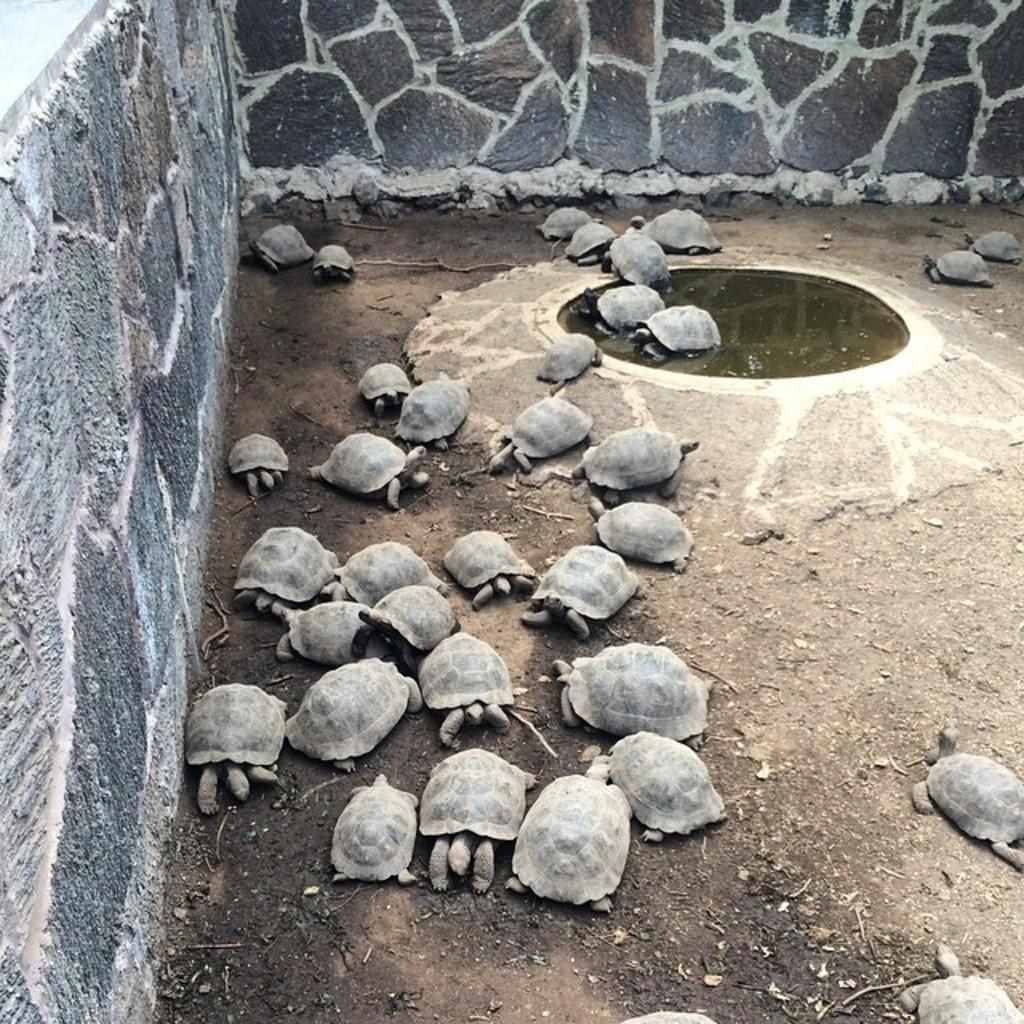What type of animals are in the image? There is a group of tortoises in the image. What can be seen in the background of the image? There is water and a wall visible in the background of the image. What type of brass instrument is being played by the tortoises in the image? There are no brass instruments or any instruments present in the image; it features a group of tortoises and a background with water and a wall. 